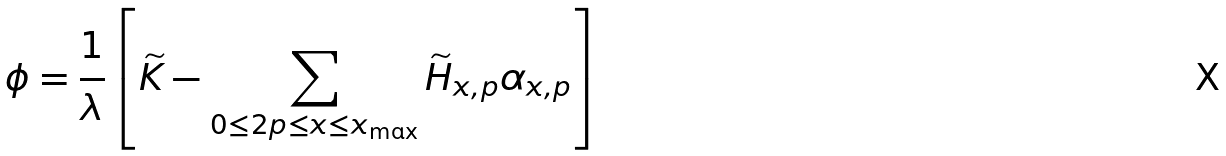Convert formula to latex. <formula><loc_0><loc_0><loc_500><loc_500>\phi = \frac { 1 } { \lambda } \left [ \widetilde { K } - \sum _ { 0 \leq 2 p \leq x \leq x _ { \max } } \widetilde { H } _ { x , p } \alpha _ { x , p } \right ]</formula> 